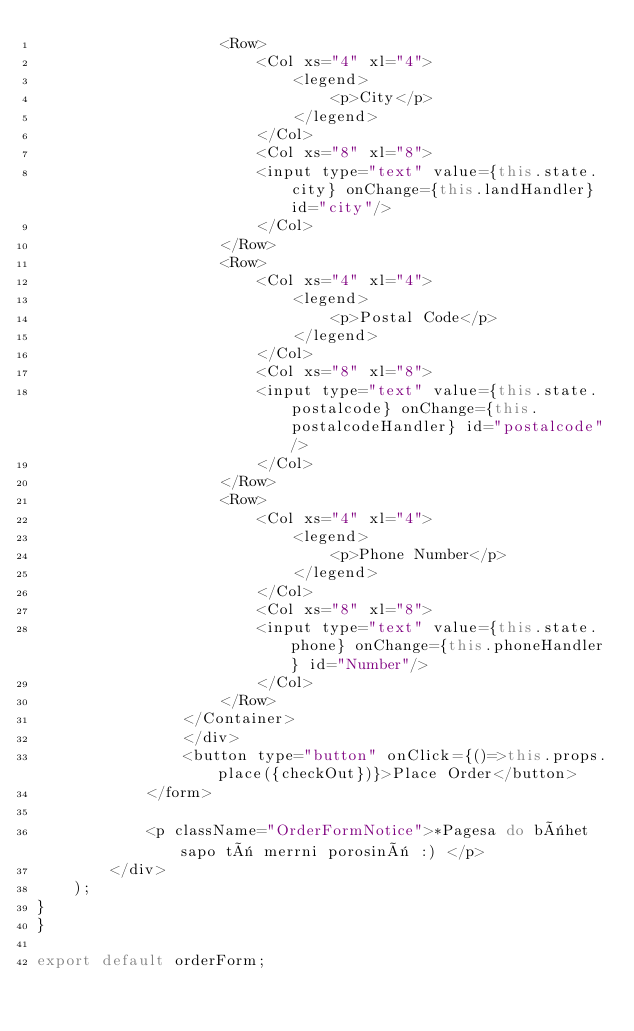<code> <loc_0><loc_0><loc_500><loc_500><_JavaScript_>                    <Row>
                        <Col xs="4" xl="4">
                            <legend>
                                <p>City</p>
                            </legend>
                        </Col>
                        <Col xs="8" xl="8">
                        <input type="text" value={this.state.city} onChange={this.landHandler} id="city"/>
                        </Col>
                    </Row>
                    <Row>
                        <Col xs="4" xl="4">
                            <legend>
                                <p>Postal Code</p>
                            </legend>
                        </Col>
                        <Col xs="8" xl="8">
                        <input type="text" value={this.state.postalcode} onChange={this.postalcodeHandler} id="postalcode"/>
                        </Col>
                    </Row>
                    <Row>
                        <Col xs="4" xl="4">
                            <legend>
                                <p>Phone Number</p>
                            </legend>
                        </Col>
                        <Col xs="8" xl="8">
                        <input type="text" value={this.state.phone} onChange={this.phoneHandler} id="Number"/>
                        </Col>
                    </Row>
                </Container>
                </div>
                <button type="button" onClick={()=>this.props.place({checkOut})}>Place Order</button>
            </form>
            
            <p className="OrderFormNotice">*Pagesa do bëhet sapo të merrni porosinë :) </p>
        </div>
    );
}
}

export default orderForm;</code> 